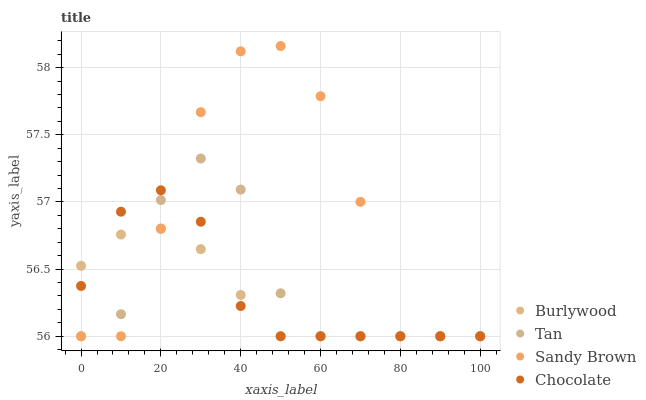Does Burlywood have the minimum area under the curve?
Answer yes or no. Yes. Does Sandy Brown have the maximum area under the curve?
Answer yes or no. Yes. Does Tan have the minimum area under the curve?
Answer yes or no. No. Does Tan have the maximum area under the curve?
Answer yes or no. No. Is Burlywood the smoothest?
Answer yes or no. Yes. Is Sandy Brown the roughest?
Answer yes or no. Yes. Is Tan the smoothest?
Answer yes or no. No. Is Tan the roughest?
Answer yes or no. No. Does Burlywood have the lowest value?
Answer yes or no. Yes. Does Sandy Brown have the highest value?
Answer yes or no. Yes. Does Tan have the highest value?
Answer yes or no. No. Does Sandy Brown intersect Burlywood?
Answer yes or no. Yes. Is Sandy Brown less than Burlywood?
Answer yes or no. No. Is Sandy Brown greater than Burlywood?
Answer yes or no. No. 